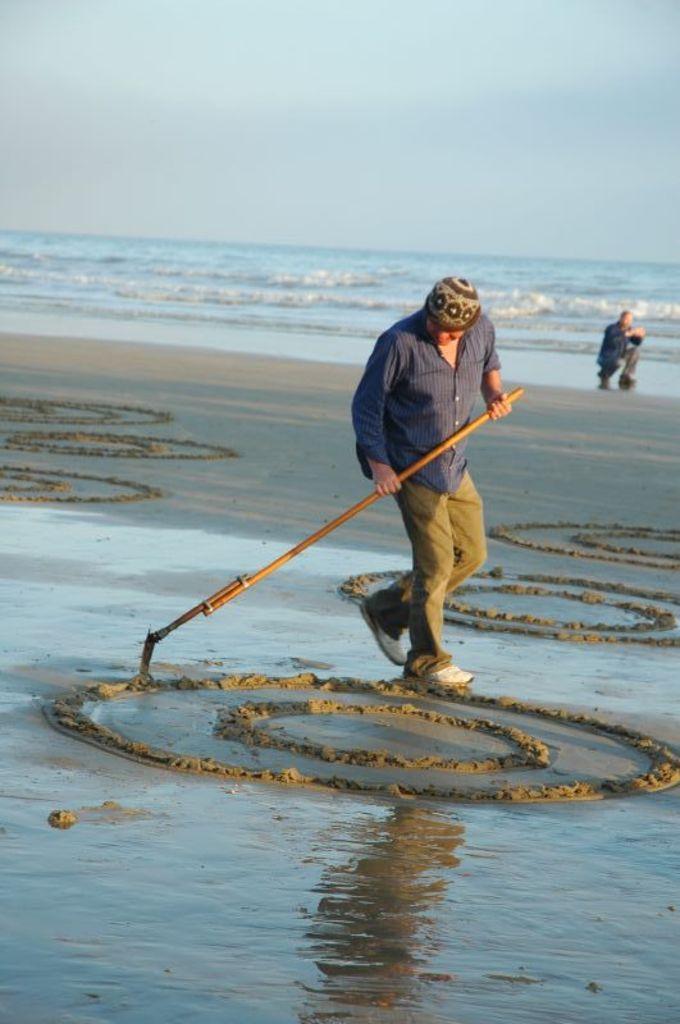Describe this image in one or two sentences. Front this person is holding a stick and drawing circles on sand. Far there is a person and water. 